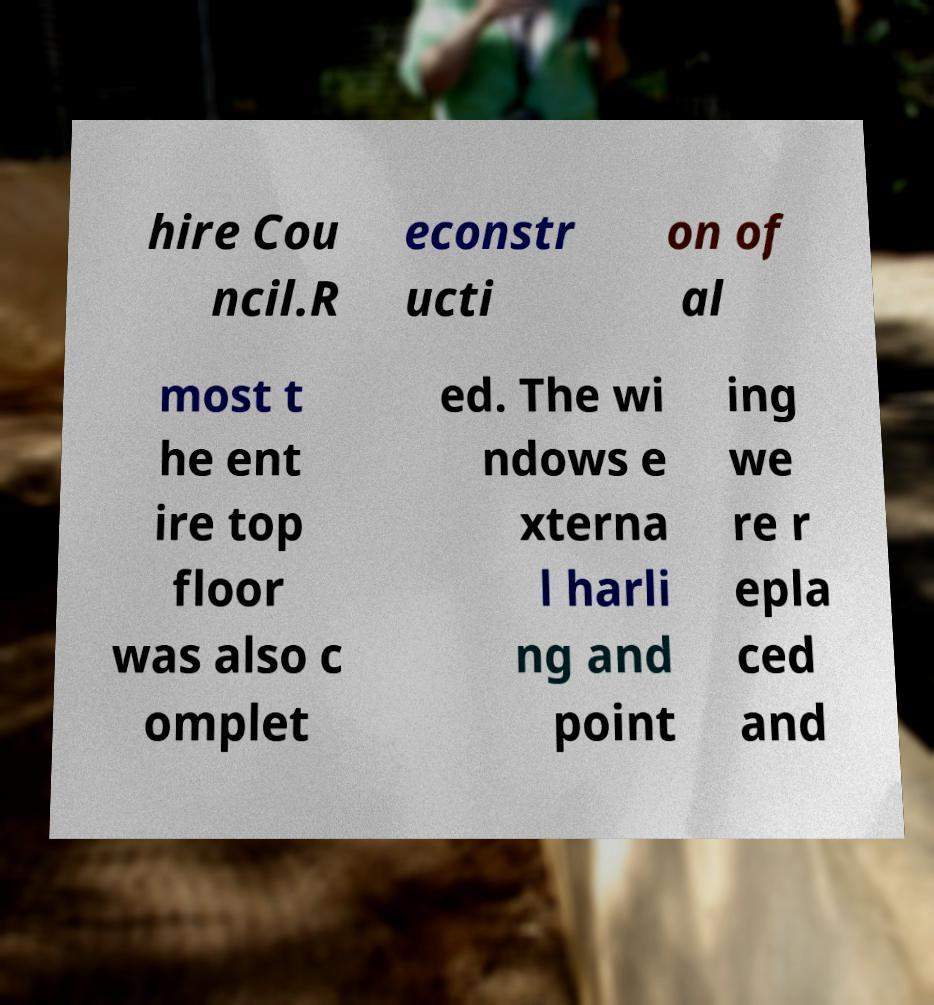There's text embedded in this image that I need extracted. Can you transcribe it verbatim? hire Cou ncil.R econstr ucti on of al most t he ent ire top floor was also c omplet ed. The wi ndows e xterna l harli ng and point ing we re r epla ced and 